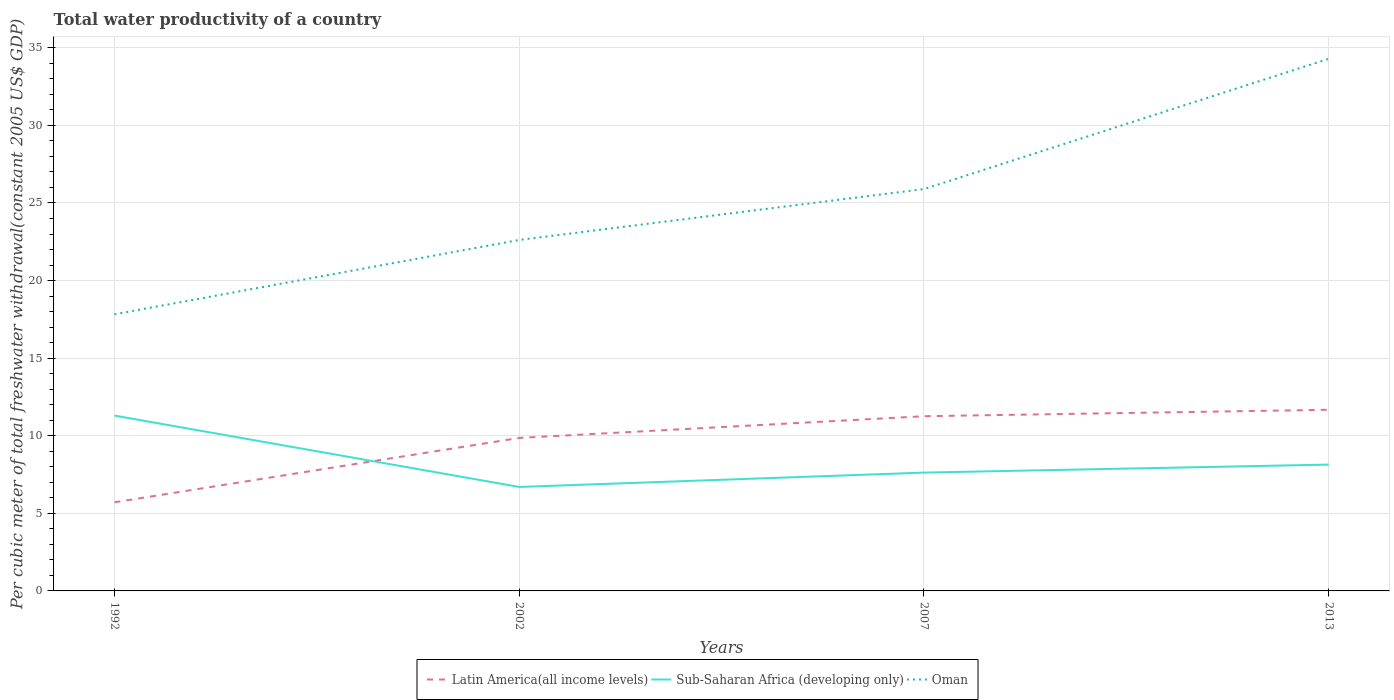How many different coloured lines are there?
Your response must be concise. 3. Does the line corresponding to Sub-Saharan Africa (developing only) intersect with the line corresponding to Latin America(all income levels)?
Your answer should be compact. Yes. Is the number of lines equal to the number of legend labels?
Your answer should be very brief. Yes. Across all years, what is the maximum total water productivity in Latin America(all income levels)?
Provide a succinct answer. 5.71. What is the total total water productivity in Oman in the graph?
Ensure brevity in your answer.  -3.28. What is the difference between the highest and the second highest total water productivity in Latin America(all income levels)?
Provide a succinct answer. 5.96. How many years are there in the graph?
Your answer should be compact. 4. Does the graph contain any zero values?
Your response must be concise. No. How many legend labels are there?
Your answer should be compact. 3. How are the legend labels stacked?
Give a very brief answer. Horizontal. What is the title of the graph?
Keep it short and to the point. Total water productivity of a country. Does "Lao PDR" appear as one of the legend labels in the graph?
Provide a short and direct response. No. What is the label or title of the X-axis?
Ensure brevity in your answer.  Years. What is the label or title of the Y-axis?
Your answer should be very brief. Per cubic meter of total freshwater withdrawal(constant 2005 US$ GDP). What is the Per cubic meter of total freshwater withdrawal(constant 2005 US$ GDP) of Latin America(all income levels) in 1992?
Offer a very short reply. 5.71. What is the Per cubic meter of total freshwater withdrawal(constant 2005 US$ GDP) of Sub-Saharan Africa (developing only) in 1992?
Provide a succinct answer. 11.3. What is the Per cubic meter of total freshwater withdrawal(constant 2005 US$ GDP) of Oman in 1992?
Your answer should be very brief. 17.83. What is the Per cubic meter of total freshwater withdrawal(constant 2005 US$ GDP) in Latin America(all income levels) in 2002?
Ensure brevity in your answer.  9.86. What is the Per cubic meter of total freshwater withdrawal(constant 2005 US$ GDP) in Sub-Saharan Africa (developing only) in 2002?
Make the answer very short. 6.7. What is the Per cubic meter of total freshwater withdrawal(constant 2005 US$ GDP) in Oman in 2002?
Your response must be concise. 22.62. What is the Per cubic meter of total freshwater withdrawal(constant 2005 US$ GDP) in Latin America(all income levels) in 2007?
Offer a terse response. 11.26. What is the Per cubic meter of total freshwater withdrawal(constant 2005 US$ GDP) in Sub-Saharan Africa (developing only) in 2007?
Provide a short and direct response. 7.63. What is the Per cubic meter of total freshwater withdrawal(constant 2005 US$ GDP) in Oman in 2007?
Offer a terse response. 25.9. What is the Per cubic meter of total freshwater withdrawal(constant 2005 US$ GDP) of Latin America(all income levels) in 2013?
Give a very brief answer. 11.67. What is the Per cubic meter of total freshwater withdrawal(constant 2005 US$ GDP) in Sub-Saharan Africa (developing only) in 2013?
Keep it short and to the point. 8.14. What is the Per cubic meter of total freshwater withdrawal(constant 2005 US$ GDP) of Oman in 2013?
Your response must be concise. 34.3. Across all years, what is the maximum Per cubic meter of total freshwater withdrawal(constant 2005 US$ GDP) in Latin America(all income levels)?
Offer a terse response. 11.67. Across all years, what is the maximum Per cubic meter of total freshwater withdrawal(constant 2005 US$ GDP) in Sub-Saharan Africa (developing only)?
Provide a short and direct response. 11.3. Across all years, what is the maximum Per cubic meter of total freshwater withdrawal(constant 2005 US$ GDP) in Oman?
Provide a succinct answer. 34.3. Across all years, what is the minimum Per cubic meter of total freshwater withdrawal(constant 2005 US$ GDP) of Latin America(all income levels)?
Your answer should be very brief. 5.71. Across all years, what is the minimum Per cubic meter of total freshwater withdrawal(constant 2005 US$ GDP) of Sub-Saharan Africa (developing only)?
Your answer should be very brief. 6.7. Across all years, what is the minimum Per cubic meter of total freshwater withdrawal(constant 2005 US$ GDP) in Oman?
Offer a very short reply. 17.83. What is the total Per cubic meter of total freshwater withdrawal(constant 2005 US$ GDP) in Latin America(all income levels) in the graph?
Make the answer very short. 38.5. What is the total Per cubic meter of total freshwater withdrawal(constant 2005 US$ GDP) in Sub-Saharan Africa (developing only) in the graph?
Keep it short and to the point. 33.77. What is the total Per cubic meter of total freshwater withdrawal(constant 2005 US$ GDP) of Oman in the graph?
Ensure brevity in your answer.  100.64. What is the difference between the Per cubic meter of total freshwater withdrawal(constant 2005 US$ GDP) in Latin America(all income levels) in 1992 and that in 2002?
Offer a terse response. -4.15. What is the difference between the Per cubic meter of total freshwater withdrawal(constant 2005 US$ GDP) of Sub-Saharan Africa (developing only) in 1992 and that in 2002?
Offer a terse response. 4.6. What is the difference between the Per cubic meter of total freshwater withdrawal(constant 2005 US$ GDP) of Oman in 1992 and that in 2002?
Your answer should be very brief. -4.79. What is the difference between the Per cubic meter of total freshwater withdrawal(constant 2005 US$ GDP) in Latin America(all income levels) in 1992 and that in 2007?
Provide a short and direct response. -5.55. What is the difference between the Per cubic meter of total freshwater withdrawal(constant 2005 US$ GDP) in Sub-Saharan Africa (developing only) in 1992 and that in 2007?
Ensure brevity in your answer.  3.67. What is the difference between the Per cubic meter of total freshwater withdrawal(constant 2005 US$ GDP) of Oman in 1992 and that in 2007?
Ensure brevity in your answer.  -8.07. What is the difference between the Per cubic meter of total freshwater withdrawal(constant 2005 US$ GDP) of Latin America(all income levels) in 1992 and that in 2013?
Your answer should be very brief. -5.96. What is the difference between the Per cubic meter of total freshwater withdrawal(constant 2005 US$ GDP) of Sub-Saharan Africa (developing only) in 1992 and that in 2013?
Ensure brevity in your answer.  3.16. What is the difference between the Per cubic meter of total freshwater withdrawal(constant 2005 US$ GDP) in Oman in 1992 and that in 2013?
Offer a very short reply. -16.47. What is the difference between the Per cubic meter of total freshwater withdrawal(constant 2005 US$ GDP) of Latin America(all income levels) in 2002 and that in 2007?
Ensure brevity in your answer.  -1.4. What is the difference between the Per cubic meter of total freshwater withdrawal(constant 2005 US$ GDP) of Sub-Saharan Africa (developing only) in 2002 and that in 2007?
Keep it short and to the point. -0.93. What is the difference between the Per cubic meter of total freshwater withdrawal(constant 2005 US$ GDP) of Oman in 2002 and that in 2007?
Ensure brevity in your answer.  -3.28. What is the difference between the Per cubic meter of total freshwater withdrawal(constant 2005 US$ GDP) of Latin America(all income levels) in 2002 and that in 2013?
Make the answer very short. -1.82. What is the difference between the Per cubic meter of total freshwater withdrawal(constant 2005 US$ GDP) in Sub-Saharan Africa (developing only) in 2002 and that in 2013?
Make the answer very short. -1.44. What is the difference between the Per cubic meter of total freshwater withdrawal(constant 2005 US$ GDP) of Oman in 2002 and that in 2013?
Provide a short and direct response. -11.68. What is the difference between the Per cubic meter of total freshwater withdrawal(constant 2005 US$ GDP) in Latin America(all income levels) in 2007 and that in 2013?
Ensure brevity in your answer.  -0.42. What is the difference between the Per cubic meter of total freshwater withdrawal(constant 2005 US$ GDP) of Sub-Saharan Africa (developing only) in 2007 and that in 2013?
Offer a terse response. -0.51. What is the difference between the Per cubic meter of total freshwater withdrawal(constant 2005 US$ GDP) of Oman in 2007 and that in 2013?
Your response must be concise. -8.4. What is the difference between the Per cubic meter of total freshwater withdrawal(constant 2005 US$ GDP) of Latin America(all income levels) in 1992 and the Per cubic meter of total freshwater withdrawal(constant 2005 US$ GDP) of Sub-Saharan Africa (developing only) in 2002?
Provide a succinct answer. -0.99. What is the difference between the Per cubic meter of total freshwater withdrawal(constant 2005 US$ GDP) in Latin America(all income levels) in 1992 and the Per cubic meter of total freshwater withdrawal(constant 2005 US$ GDP) in Oman in 2002?
Your answer should be very brief. -16.91. What is the difference between the Per cubic meter of total freshwater withdrawal(constant 2005 US$ GDP) of Sub-Saharan Africa (developing only) in 1992 and the Per cubic meter of total freshwater withdrawal(constant 2005 US$ GDP) of Oman in 2002?
Make the answer very short. -11.32. What is the difference between the Per cubic meter of total freshwater withdrawal(constant 2005 US$ GDP) in Latin America(all income levels) in 1992 and the Per cubic meter of total freshwater withdrawal(constant 2005 US$ GDP) in Sub-Saharan Africa (developing only) in 2007?
Offer a very short reply. -1.91. What is the difference between the Per cubic meter of total freshwater withdrawal(constant 2005 US$ GDP) in Latin America(all income levels) in 1992 and the Per cubic meter of total freshwater withdrawal(constant 2005 US$ GDP) in Oman in 2007?
Your answer should be very brief. -20.19. What is the difference between the Per cubic meter of total freshwater withdrawal(constant 2005 US$ GDP) of Sub-Saharan Africa (developing only) in 1992 and the Per cubic meter of total freshwater withdrawal(constant 2005 US$ GDP) of Oman in 2007?
Offer a very short reply. -14.6. What is the difference between the Per cubic meter of total freshwater withdrawal(constant 2005 US$ GDP) in Latin America(all income levels) in 1992 and the Per cubic meter of total freshwater withdrawal(constant 2005 US$ GDP) in Sub-Saharan Africa (developing only) in 2013?
Your answer should be very brief. -2.43. What is the difference between the Per cubic meter of total freshwater withdrawal(constant 2005 US$ GDP) of Latin America(all income levels) in 1992 and the Per cubic meter of total freshwater withdrawal(constant 2005 US$ GDP) of Oman in 2013?
Your response must be concise. -28.58. What is the difference between the Per cubic meter of total freshwater withdrawal(constant 2005 US$ GDP) of Sub-Saharan Africa (developing only) in 1992 and the Per cubic meter of total freshwater withdrawal(constant 2005 US$ GDP) of Oman in 2013?
Offer a very short reply. -22.99. What is the difference between the Per cubic meter of total freshwater withdrawal(constant 2005 US$ GDP) of Latin America(all income levels) in 2002 and the Per cubic meter of total freshwater withdrawal(constant 2005 US$ GDP) of Sub-Saharan Africa (developing only) in 2007?
Your answer should be very brief. 2.23. What is the difference between the Per cubic meter of total freshwater withdrawal(constant 2005 US$ GDP) of Latin America(all income levels) in 2002 and the Per cubic meter of total freshwater withdrawal(constant 2005 US$ GDP) of Oman in 2007?
Offer a very short reply. -16.04. What is the difference between the Per cubic meter of total freshwater withdrawal(constant 2005 US$ GDP) of Sub-Saharan Africa (developing only) in 2002 and the Per cubic meter of total freshwater withdrawal(constant 2005 US$ GDP) of Oman in 2007?
Your answer should be very brief. -19.2. What is the difference between the Per cubic meter of total freshwater withdrawal(constant 2005 US$ GDP) in Latin America(all income levels) in 2002 and the Per cubic meter of total freshwater withdrawal(constant 2005 US$ GDP) in Sub-Saharan Africa (developing only) in 2013?
Keep it short and to the point. 1.72. What is the difference between the Per cubic meter of total freshwater withdrawal(constant 2005 US$ GDP) in Latin America(all income levels) in 2002 and the Per cubic meter of total freshwater withdrawal(constant 2005 US$ GDP) in Oman in 2013?
Offer a terse response. -24.44. What is the difference between the Per cubic meter of total freshwater withdrawal(constant 2005 US$ GDP) of Sub-Saharan Africa (developing only) in 2002 and the Per cubic meter of total freshwater withdrawal(constant 2005 US$ GDP) of Oman in 2013?
Provide a succinct answer. -27.6. What is the difference between the Per cubic meter of total freshwater withdrawal(constant 2005 US$ GDP) in Latin America(all income levels) in 2007 and the Per cubic meter of total freshwater withdrawal(constant 2005 US$ GDP) in Sub-Saharan Africa (developing only) in 2013?
Your answer should be very brief. 3.12. What is the difference between the Per cubic meter of total freshwater withdrawal(constant 2005 US$ GDP) in Latin America(all income levels) in 2007 and the Per cubic meter of total freshwater withdrawal(constant 2005 US$ GDP) in Oman in 2013?
Your answer should be very brief. -23.04. What is the difference between the Per cubic meter of total freshwater withdrawal(constant 2005 US$ GDP) in Sub-Saharan Africa (developing only) in 2007 and the Per cubic meter of total freshwater withdrawal(constant 2005 US$ GDP) in Oman in 2013?
Keep it short and to the point. -26.67. What is the average Per cubic meter of total freshwater withdrawal(constant 2005 US$ GDP) of Latin America(all income levels) per year?
Keep it short and to the point. 9.63. What is the average Per cubic meter of total freshwater withdrawal(constant 2005 US$ GDP) of Sub-Saharan Africa (developing only) per year?
Make the answer very short. 8.44. What is the average Per cubic meter of total freshwater withdrawal(constant 2005 US$ GDP) in Oman per year?
Provide a short and direct response. 25.16. In the year 1992, what is the difference between the Per cubic meter of total freshwater withdrawal(constant 2005 US$ GDP) of Latin America(all income levels) and Per cubic meter of total freshwater withdrawal(constant 2005 US$ GDP) of Sub-Saharan Africa (developing only)?
Your answer should be compact. -5.59. In the year 1992, what is the difference between the Per cubic meter of total freshwater withdrawal(constant 2005 US$ GDP) of Latin America(all income levels) and Per cubic meter of total freshwater withdrawal(constant 2005 US$ GDP) of Oman?
Your answer should be very brief. -12.12. In the year 1992, what is the difference between the Per cubic meter of total freshwater withdrawal(constant 2005 US$ GDP) in Sub-Saharan Africa (developing only) and Per cubic meter of total freshwater withdrawal(constant 2005 US$ GDP) in Oman?
Keep it short and to the point. -6.53. In the year 2002, what is the difference between the Per cubic meter of total freshwater withdrawal(constant 2005 US$ GDP) of Latin America(all income levels) and Per cubic meter of total freshwater withdrawal(constant 2005 US$ GDP) of Sub-Saharan Africa (developing only)?
Give a very brief answer. 3.16. In the year 2002, what is the difference between the Per cubic meter of total freshwater withdrawal(constant 2005 US$ GDP) of Latin America(all income levels) and Per cubic meter of total freshwater withdrawal(constant 2005 US$ GDP) of Oman?
Ensure brevity in your answer.  -12.76. In the year 2002, what is the difference between the Per cubic meter of total freshwater withdrawal(constant 2005 US$ GDP) of Sub-Saharan Africa (developing only) and Per cubic meter of total freshwater withdrawal(constant 2005 US$ GDP) of Oman?
Your response must be concise. -15.92. In the year 2007, what is the difference between the Per cubic meter of total freshwater withdrawal(constant 2005 US$ GDP) in Latin America(all income levels) and Per cubic meter of total freshwater withdrawal(constant 2005 US$ GDP) in Sub-Saharan Africa (developing only)?
Offer a terse response. 3.63. In the year 2007, what is the difference between the Per cubic meter of total freshwater withdrawal(constant 2005 US$ GDP) of Latin America(all income levels) and Per cubic meter of total freshwater withdrawal(constant 2005 US$ GDP) of Oman?
Offer a very short reply. -14.64. In the year 2007, what is the difference between the Per cubic meter of total freshwater withdrawal(constant 2005 US$ GDP) of Sub-Saharan Africa (developing only) and Per cubic meter of total freshwater withdrawal(constant 2005 US$ GDP) of Oman?
Provide a short and direct response. -18.27. In the year 2013, what is the difference between the Per cubic meter of total freshwater withdrawal(constant 2005 US$ GDP) of Latin America(all income levels) and Per cubic meter of total freshwater withdrawal(constant 2005 US$ GDP) of Sub-Saharan Africa (developing only)?
Offer a very short reply. 3.53. In the year 2013, what is the difference between the Per cubic meter of total freshwater withdrawal(constant 2005 US$ GDP) in Latin America(all income levels) and Per cubic meter of total freshwater withdrawal(constant 2005 US$ GDP) in Oman?
Ensure brevity in your answer.  -22.62. In the year 2013, what is the difference between the Per cubic meter of total freshwater withdrawal(constant 2005 US$ GDP) of Sub-Saharan Africa (developing only) and Per cubic meter of total freshwater withdrawal(constant 2005 US$ GDP) of Oman?
Your answer should be very brief. -26.15. What is the ratio of the Per cubic meter of total freshwater withdrawal(constant 2005 US$ GDP) of Latin America(all income levels) in 1992 to that in 2002?
Your answer should be very brief. 0.58. What is the ratio of the Per cubic meter of total freshwater withdrawal(constant 2005 US$ GDP) of Sub-Saharan Africa (developing only) in 1992 to that in 2002?
Make the answer very short. 1.69. What is the ratio of the Per cubic meter of total freshwater withdrawal(constant 2005 US$ GDP) of Oman in 1992 to that in 2002?
Offer a terse response. 0.79. What is the ratio of the Per cubic meter of total freshwater withdrawal(constant 2005 US$ GDP) in Latin America(all income levels) in 1992 to that in 2007?
Your answer should be compact. 0.51. What is the ratio of the Per cubic meter of total freshwater withdrawal(constant 2005 US$ GDP) of Sub-Saharan Africa (developing only) in 1992 to that in 2007?
Ensure brevity in your answer.  1.48. What is the ratio of the Per cubic meter of total freshwater withdrawal(constant 2005 US$ GDP) in Oman in 1992 to that in 2007?
Your response must be concise. 0.69. What is the ratio of the Per cubic meter of total freshwater withdrawal(constant 2005 US$ GDP) of Latin America(all income levels) in 1992 to that in 2013?
Provide a succinct answer. 0.49. What is the ratio of the Per cubic meter of total freshwater withdrawal(constant 2005 US$ GDP) of Sub-Saharan Africa (developing only) in 1992 to that in 2013?
Provide a short and direct response. 1.39. What is the ratio of the Per cubic meter of total freshwater withdrawal(constant 2005 US$ GDP) in Oman in 1992 to that in 2013?
Offer a terse response. 0.52. What is the ratio of the Per cubic meter of total freshwater withdrawal(constant 2005 US$ GDP) of Latin America(all income levels) in 2002 to that in 2007?
Ensure brevity in your answer.  0.88. What is the ratio of the Per cubic meter of total freshwater withdrawal(constant 2005 US$ GDP) in Sub-Saharan Africa (developing only) in 2002 to that in 2007?
Keep it short and to the point. 0.88. What is the ratio of the Per cubic meter of total freshwater withdrawal(constant 2005 US$ GDP) in Oman in 2002 to that in 2007?
Offer a very short reply. 0.87. What is the ratio of the Per cubic meter of total freshwater withdrawal(constant 2005 US$ GDP) in Latin America(all income levels) in 2002 to that in 2013?
Provide a short and direct response. 0.84. What is the ratio of the Per cubic meter of total freshwater withdrawal(constant 2005 US$ GDP) of Sub-Saharan Africa (developing only) in 2002 to that in 2013?
Ensure brevity in your answer.  0.82. What is the ratio of the Per cubic meter of total freshwater withdrawal(constant 2005 US$ GDP) in Oman in 2002 to that in 2013?
Ensure brevity in your answer.  0.66. What is the ratio of the Per cubic meter of total freshwater withdrawal(constant 2005 US$ GDP) of Latin America(all income levels) in 2007 to that in 2013?
Your answer should be very brief. 0.96. What is the ratio of the Per cubic meter of total freshwater withdrawal(constant 2005 US$ GDP) of Sub-Saharan Africa (developing only) in 2007 to that in 2013?
Provide a short and direct response. 0.94. What is the ratio of the Per cubic meter of total freshwater withdrawal(constant 2005 US$ GDP) of Oman in 2007 to that in 2013?
Offer a very short reply. 0.76. What is the difference between the highest and the second highest Per cubic meter of total freshwater withdrawal(constant 2005 US$ GDP) in Latin America(all income levels)?
Your response must be concise. 0.42. What is the difference between the highest and the second highest Per cubic meter of total freshwater withdrawal(constant 2005 US$ GDP) of Sub-Saharan Africa (developing only)?
Provide a succinct answer. 3.16. What is the difference between the highest and the second highest Per cubic meter of total freshwater withdrawal(constant 2005 US$ GDP) in Oman?
Provide a short and direct response. 8.4. What is the difference between the highest and the lowest Per cubic meter of total freshwater withdrawal(constant 2005 US$ GDP) in Latin America(all income levels)?
Offer a terse response. 5.96. What is the difference between the highest and the lowest Per cubic meter of total freshwater withdrawal(constant 2005 US$ GDP) of Sub-Saharan Africa (developing only)?
Make the answer very short. 4.6. What is the difference between the highest and the lowest Per cubic meter of total freshwater withdrawal(constant 2005 US$ GDP) of Oman?
Ensure brevity in your answer.  16.47. 